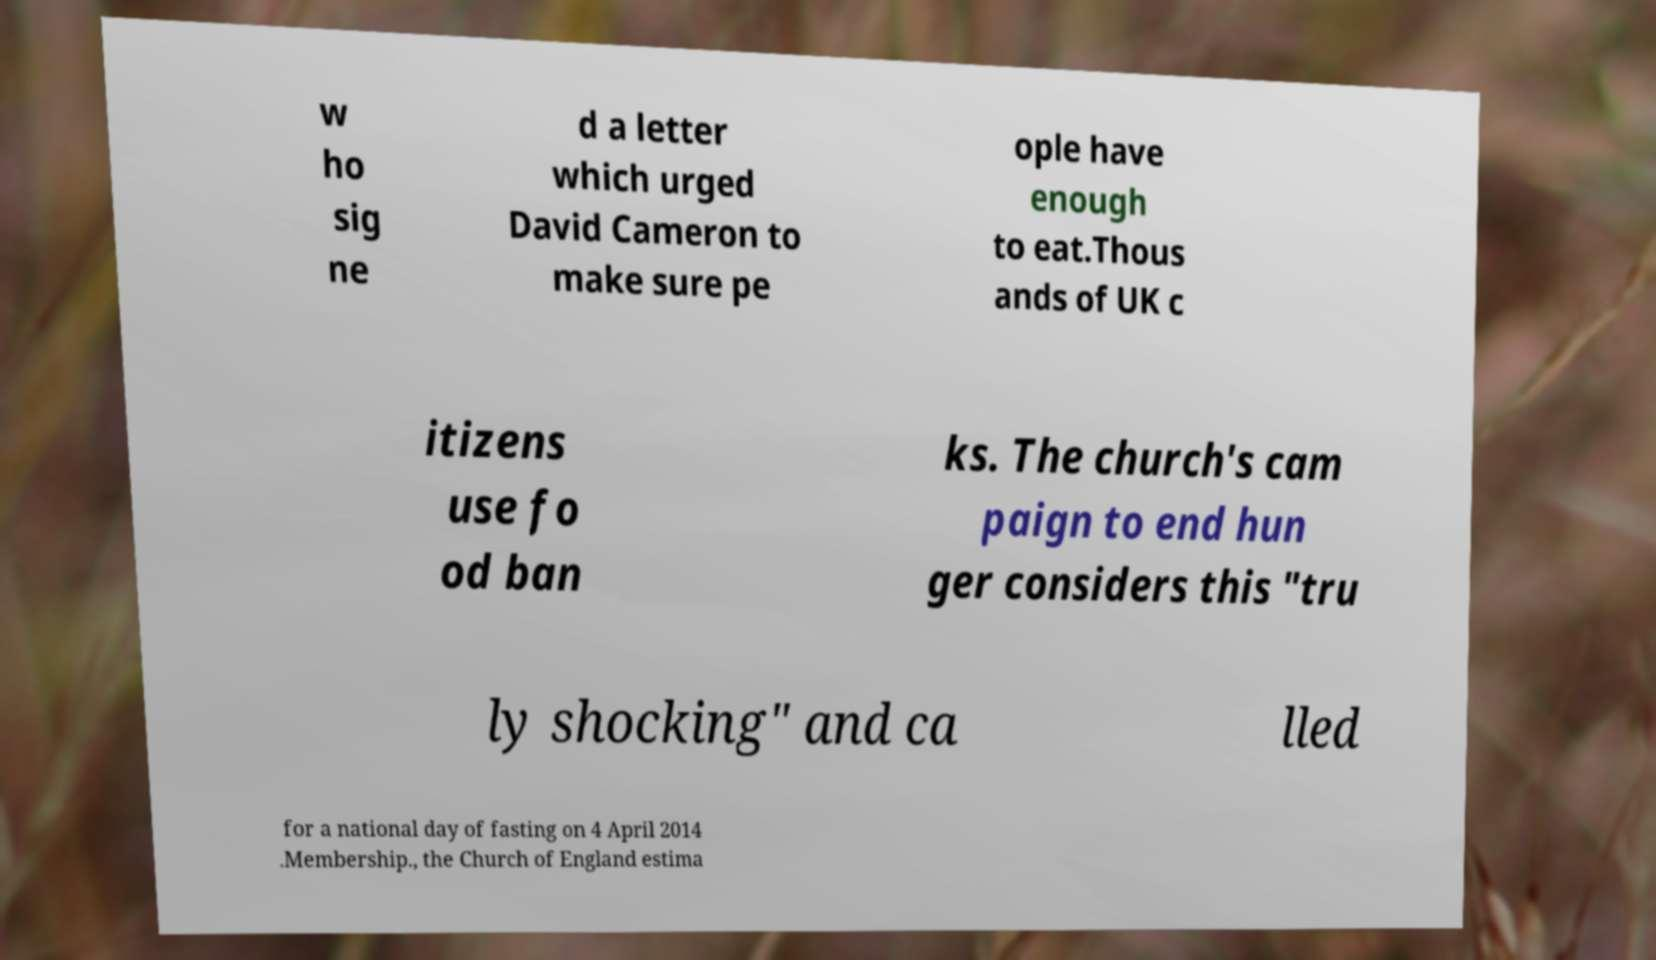Please read and relay the text visible in this image. What does it say? w ho sig ne d a letter which urged David Cameron to make sure pe ople have enough to eat.Thous ands of UK c itizens use fo od ban ks. The church's cam paign to end hun ger considers this "tru ly shocking" and ca lled for a national day of fasting on 4 April 2014 .Membership., the Church of England estima 